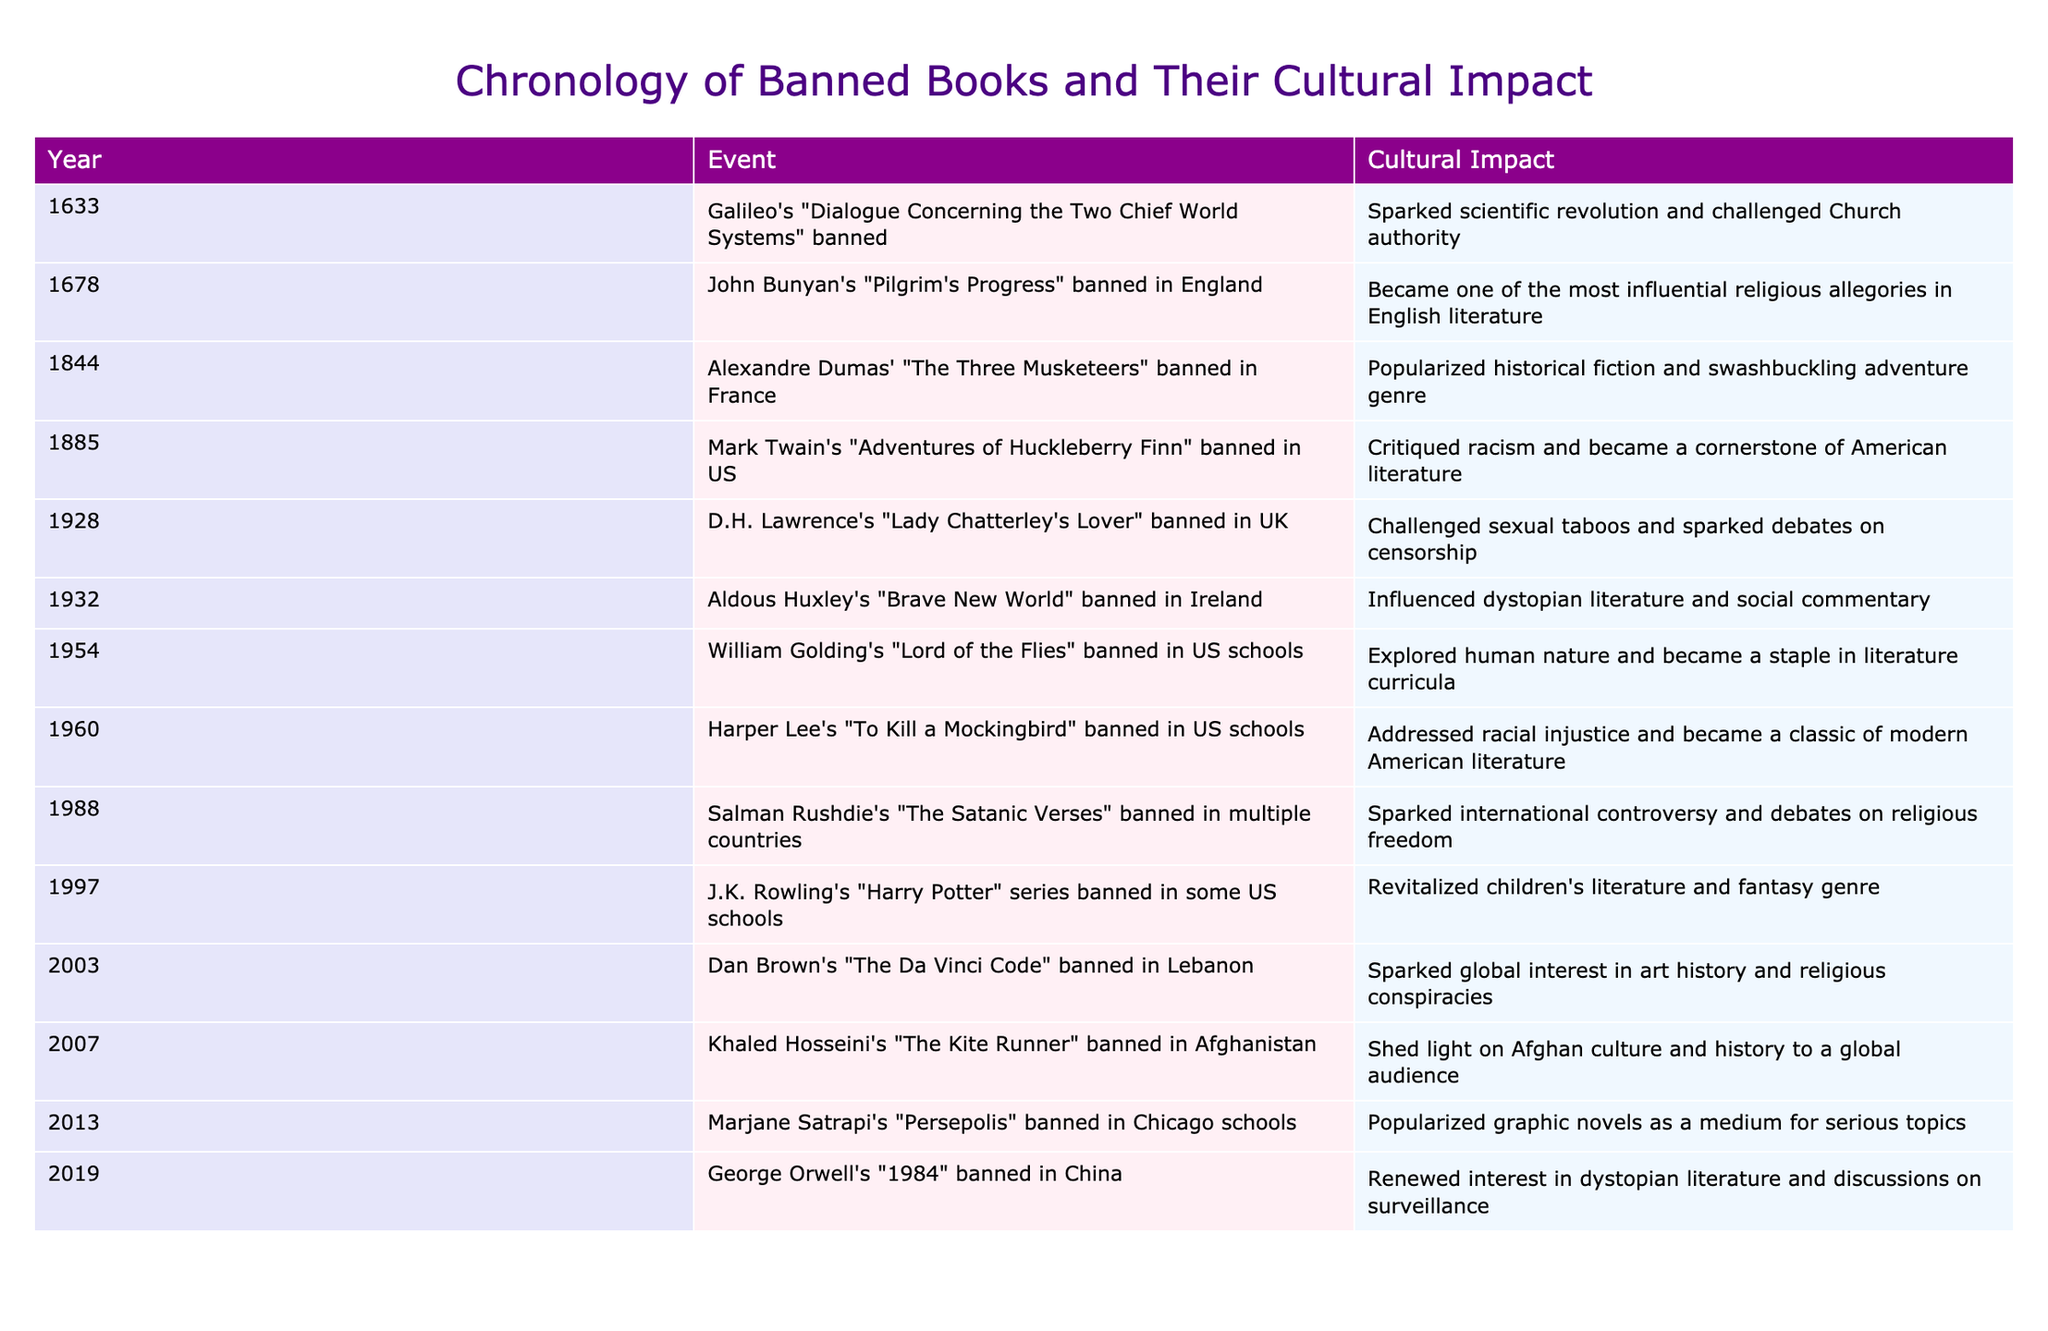What year was "Brave New World" banned in Ireland? The table directly lists the year each book was banned, for "Brave New World" it states 1932.
Answer: 1932 Which book banned in the US critiqued racism? Looking under the "Cultural Impact" column, "Adventures of Huckleberry Finn," banned in 1885, is noted for critiquing racism, making it the answer.
Answer: "Adventures of Huckleberry Finn" How many books were banned in the 20th century? By examining the years from the table, the banned books in the 20th century are "Lady Chatterley's Lover" (1928), "Brave New World" (1932), "Lord of the Flies" (1954), "To Kill a Mockingbird" (1960), "The Satanic Verses" (1988), "Harry Potter" series (1997), "The Kite Runner" (2007), "Persepolis" (2013), and "1984" (2019). That gives us eight books banned in the 20th century.
Answer: 8 Did any books banned in the 21st century focus on racial or cultural issues? From the table, "The Kite Runner" banned in 2007 focuses on Afghan culture and history, while "To Kill a Mockingbird" (banned earlier) addresses racial injustice, indicating there are books focusing on such issues.
Answer: Yes Which banned book influenced dystopian literature? The table shows that "Brave New World," banned in 1932, is credited with influencing dystopian literature; thus, that is the answer.
Answer: "Brave New World" How many of the banned books were influential in promoting discussions on censorship? The books "Lady Chatterley's Lover," "The Satanic Verses," and "1984" are specifically mentioned for their influences on censorship discussions, totaling three books.
Answer: 3 In what areas did banned books influence, based on this table? The books influenced various areas: "Pilgrim's Progress" in religious allegory, "Huckleberry Finn" in racism critique, "Brave New World" in dystopian literature, and "The Kite Runner" in Afghan culture, among others, indicating a wide range of influences.
Answer: Religion, Racism, Dystopian themes, Afghan culture Which book banned has had the most significant cultural impact related to children's literature? According to the table, "Harry Potter," banned in 1997, revitalized children's literature and the fantasy genre, marking it as the book with significant cultural impact in that area.
Answer: "Harry Potter" How does the banning of "1984" reflect contemporary issues? The table states that "1984" banned in China in 2019 renewed interest in discussions of surveillance, connecting its themes to contemporary issues on privacy and control in society.
Answer: Surveillance and control 